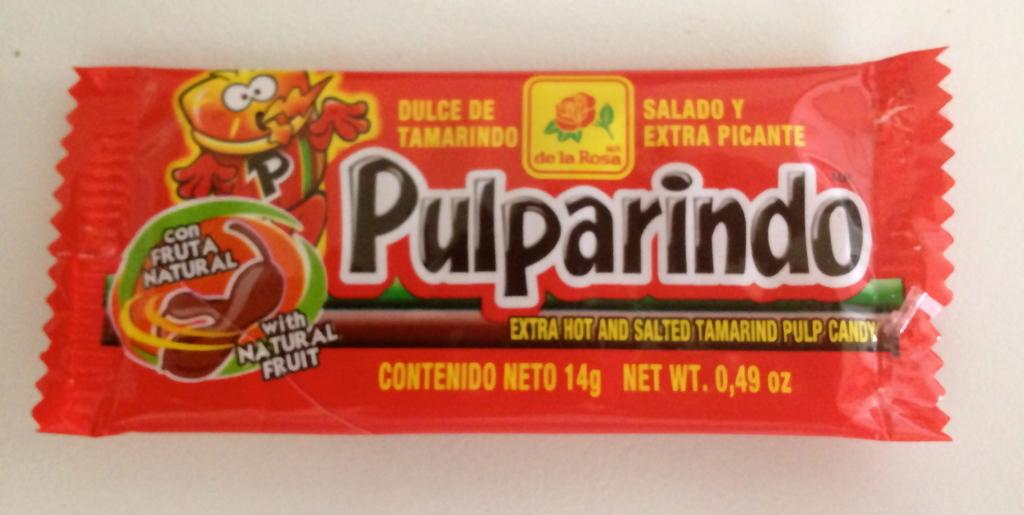<image>
Relay a brief, clear account of the picture shown. the word Pulparindo is on a piece of candy 